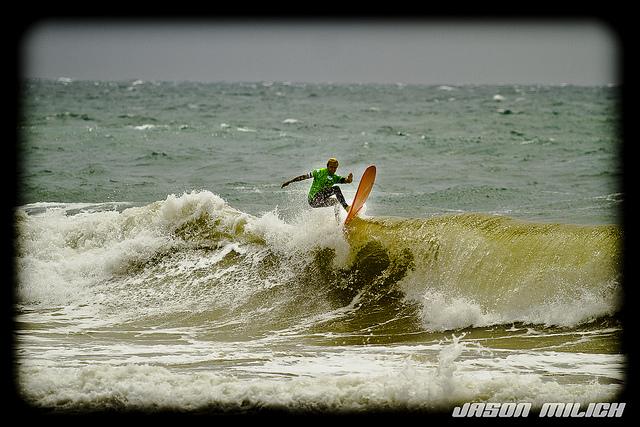How many people are shown?
Short answer required. 1. Is the man's shirt green?
Answer briefly. Yes. What is the man doing?
Be succinct. Surfing. 